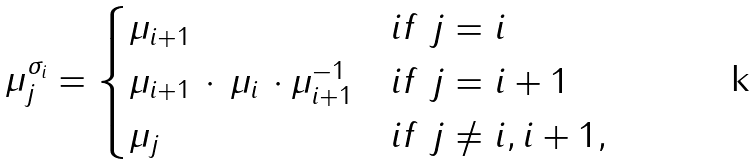<formula> <loc_0><loc_0><loc_500><loc_500>\mu _ { j } ^ { \sigma _ { i } } = \begin{cases} \mu _ { i + 1 } & i f \ j = i \\ \mu _ { i + 1 } \, \cdot \, \mu _ { i } \, \cdot \mu _ { i + 1 } ^ { - 1 } & i f \ j = i + 1 \\ \mu _ { j } & i f \ j \neq i , i + 1 , \end{cases}</formula> 